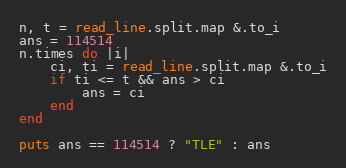Convert code to text. <code><loc_0><loc_0><loc_500><loc_500><_Crystal_>n, t = read_line.split.map &.to_i
ans = 114514
n.times do |i|
    ci, ti = read_line.split.map &.to_i
    if ti <= t && ans > ci
        ans = ci
    end
end

puts ans == 114514 ? "TLE" : ans</code> 